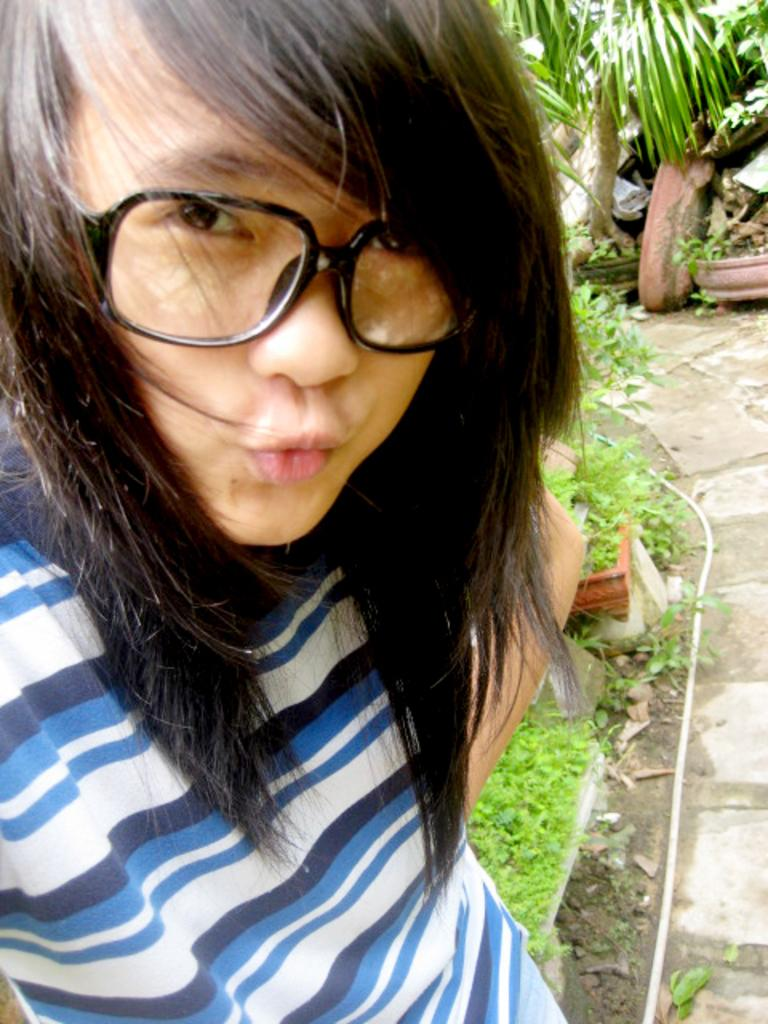Who is present in the image? There is a woman in the image. What is the woman wearing? The woman is wearing glasses. What is the woman doing in the image? The woman is watching something. What can be seen on the right side of the image? There is a walkway, pipes, plants, pots, and other objects on the right side of the image. What type of game is the woman playing in the image? There is no game present in the image; the woman is watching something. What is the rhythm of the music in the image? There is no music or rhythm mentioned in the image; it only shows a woman watching something and various objects on the right side. 